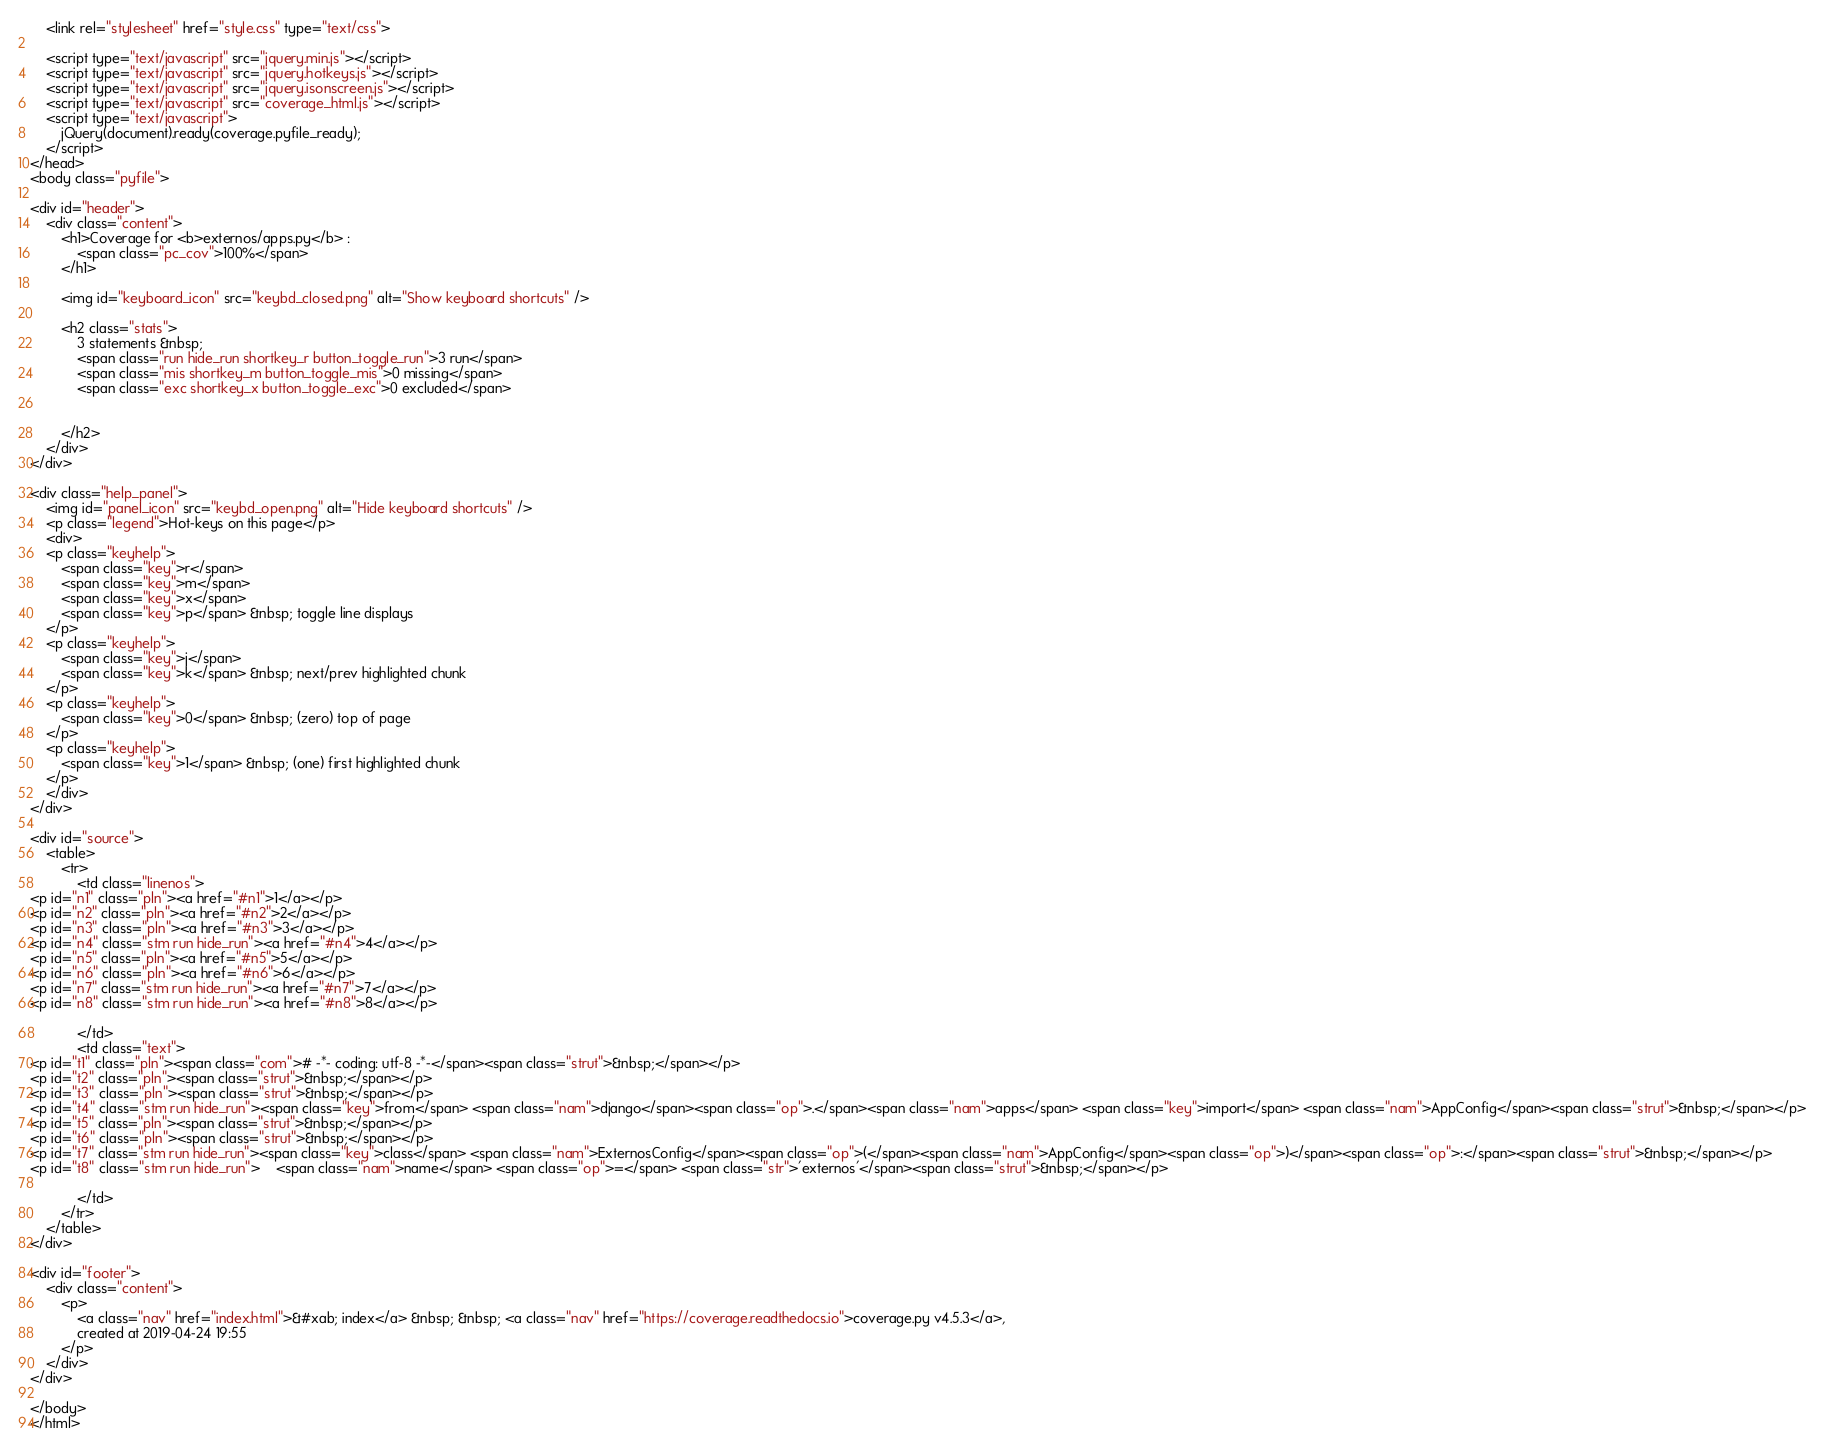<code> <loc_0><loc_0><loc_500><loc_500><_HTML_>    <link rel="stylesheet" href="style.css" type="text/css">
    
    <script type="text/javascript" src="jquery.min.js"></script>
    <script type="text/javascript" src="jquery.hotkeys.js"></script>
    <script type="text/javascript" src="jquery.isonscreen.js"></script>
    <script type="text/javascript" src="coverage_html.js"></script>
    <script type="text/javascript">
        jQuery(document).ready(coverage.pyfile_ready);
    </script>
</head>
<body class="pyfile">

<div id="header">
    <div class="content">
        <h1>Coverage for <b>externos/apps.py</b> :
            <span class="pc_cov">100%</span>
        </h1>

        <img id="keyboard_icon" src="keybd_closed.png" alt="Show keyboard shortcuts" />

        <h2 class="stats">
            3 statements &nbsp;
            <span class="run hide_run shortkey_r button_toggle_run">3 run</span>
            <span class="mis shortkey_m button_toggle_mis">0 missing</span>
            <span class="exc shortkey_x button_toggle_exc">0 excluded</span>

            
        </h2>
    </div>
</div>

<div class="help_panel">
    <img id="panel_icon" src="keybd_open.png" alt="Hide keyboard shortcuts" />
    <p class="legend">Hot-keys on this page</p>
    <div>
    <p class="keyhelp">
        <span class="key">r</span>
        <span class="key">m</span>
        <span class="key">x</span>
        <span class="key">p</span> &nbsp; toggle line displays
    </p>
    <p class="keyhelp">
        <span class="key">j</span>
        <span class="key">k</span> &nbsp; next/prev highlighted chunk
    </p>
    <p class="keyhelp">
        <span class="key">0</span> &nbsp; (zero) top of page
    </p>
    <p class="keyhelp">
        <span class="key">1</span> &nbsp; (one) first highlighted chunk
    </p>
    </div>
</div>

<div id="source">
    <table>
        <tr>
            <td class="linenos">
<p id="n1" class="pln"><a href="#n1">1</a></p>
<p id="n2" class="pln"><a href="#n2">2</a></p>
<p id="n3" class="pln"><a href="#n3">3</a></p>
<p id="n4" class="stm run hide_run"><a href="#n4">4</a></p>
<p id="n5" class="pln"><a href="#n5">5</a></p>
<p id="n6" class="pln"><a href="#n6">6</a></p>
<p id="n7" class="stm run hide_run"><a href="#n7">7</a></p>
<p id="n8" class="stm run hide_run"><a href="#n8">8</a></p>

            </td>
            <td class="text">
<p id="t1" class="pln"><span class="com"># -*- coding: utf-8 -*-</span><span class="strut">&nbsp;</span></p>
<p id="t2" class="pln"><span class="strut">&nbsp;</span></p>
<p id="t3" class="pln"><span class="strut">&nbsp;</span></p>
<p id="t4" class="stm run hide_run"><span class="key">from</span> <span class="nam">django</span><span class="op">.</span><span class="nam">apps</span> <span class="key">import</span> <span class="nam">AppConfig</span><span class="strut">&nbsp;</span></p>
<p id="t5" class="pln"><span class="strut">&nbsp;</span></p>
<p id="t6" class="pln"><span class="strut">&nbsp;</span></p>
<p id="t7" class="stm run hide_run"><span class="key">class</span> <span class="nam">ExternosConfig</span><span class="op">(</span><span class="nam">AppConfig</span><span class="op">)</span><span class="op">:</span><span class="strut">&nbsp;</span></p>
<p id="t8" class="stm run hide_run">    <span class="nam">name</span> <span class="op">=</span> <span class="str">'externos'</span><span class="strut">&nbsp;</span></p>

            </td>
        </tr>
    </table>
</div>

<div id="footer">
    <div class="content">
        <p>
            <a class="nav" href="index.html">&#xab; index</a> &nbsp; &nbsp; <a class="nav" href="https://coverage.readthedocs.io">coverage.py v4.5.3</a>,
            created at 2019-04-24 19:55
        </p>
    </div>
</div>

</body>
</html>
</code> 